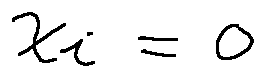<formula> <loc_0><loc_0><loc_500><loc_500>x _ { i } = 0</formula> 